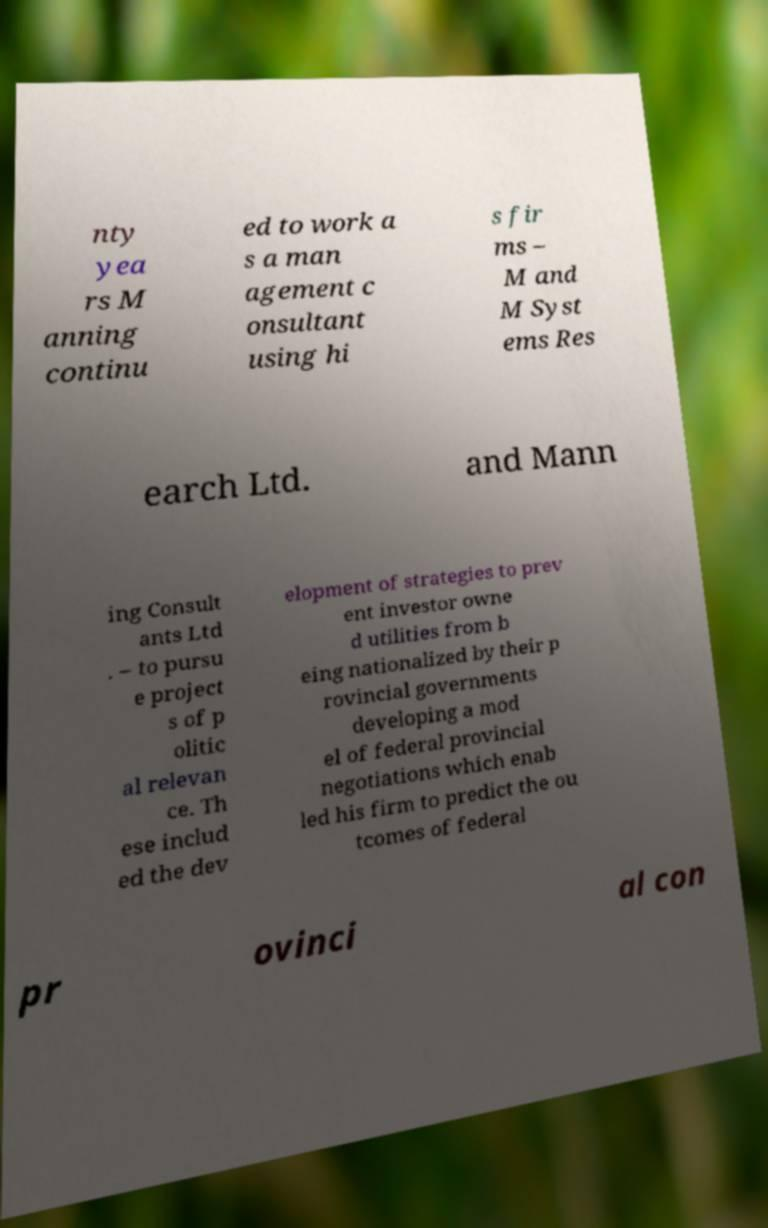What messages or text are displayed in this image? I need them in a readable, typed format. nty yea rs M anning continu ed to work a s a man agement c onsultant using hi s fir ms – M and M Syst ems Res earch Ltd. and Mann ing Consult ants Ltd . – to pursu e project s of p olitic al relevan ce. Th ese includ ed the dev elopment of strategies to prev ent investor owne d utilities from b eing nationalized by their p rovincial governments developing a mod el of federal provincial negotiations which enab led his firm to predict the ou tcomes of federal pr ovinci al con 